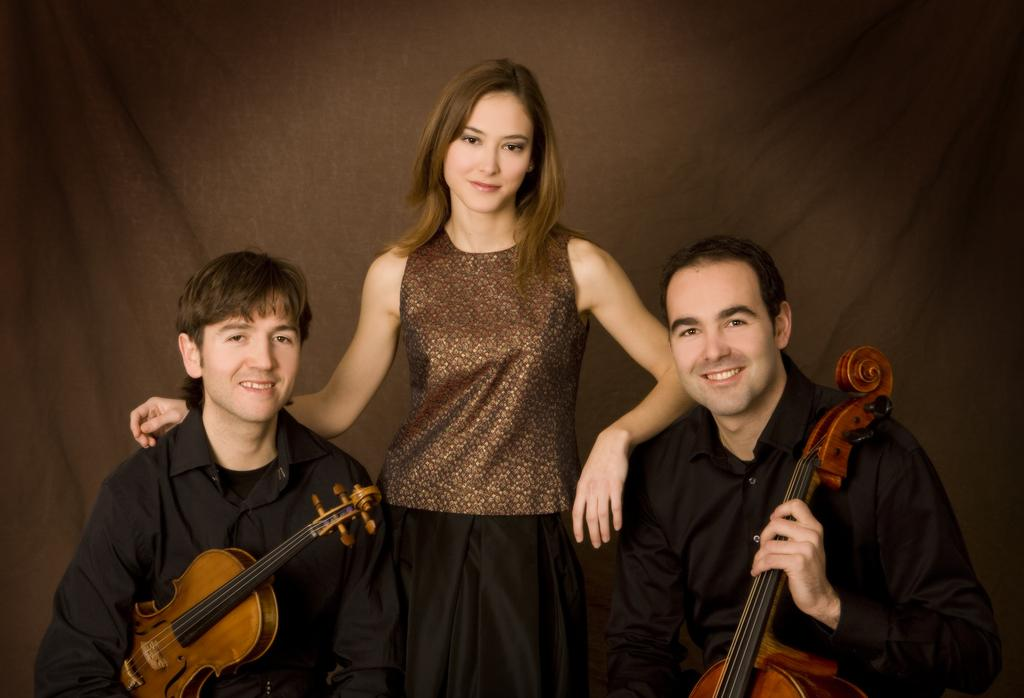How many people are in the image? There are three people in the image: a woman and two men. What are the people in the image doing? The woman and men are holding a guitar with their hands. Where are the people located in the image? They are in the middle of the image. What can be seen in the background of the image? There is a cloth visible in the background of the image. What type of fuel is being used by the cake in the image? There is no cake present in the image, so the type of fuel being used cannot be determined. 